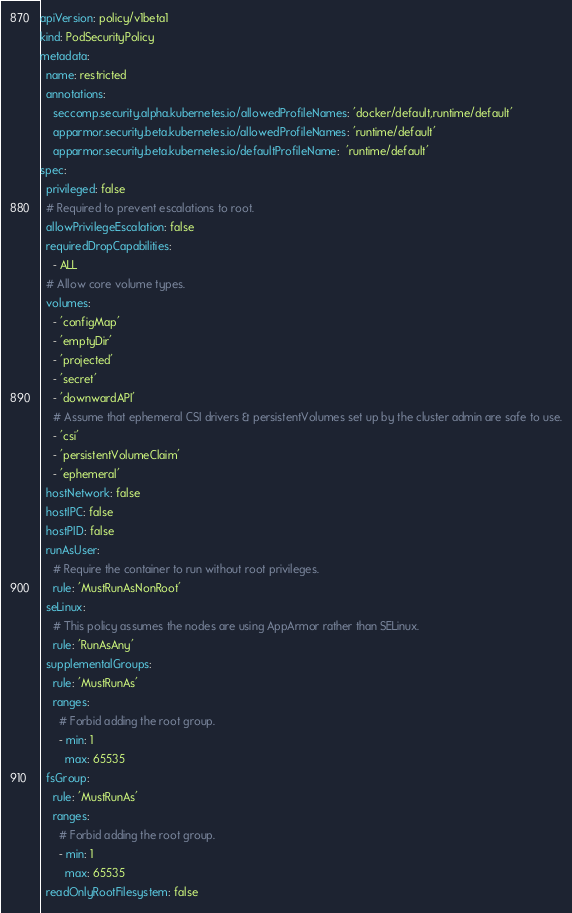Convert code to text. <code><loc_0><loc_0><loc_500><loc_500><_YAML_>apiVersion: policy/v1beta1
kind: PodSecurityPolicy
metadata:
  name: restricted
  annotations:
    seccomp.security.alpha.kubernetes.io/allowedProfileNames: 'docker/default,runtime/default'
    apparmor.security.beta.kubernetes.io/allowedProfileNames: 'runtime/default'
    apparmor.security.beta.kubernetes.io/defaultProfileName:  'runtime/default'
spec:
  privileged: false
  # Required to prevent escalations to root.
  allowPrivilegeEscalation: false
  requiredDropCapabilities:
    - ALL
  # Allow core volume types.
  volumes:
    - 'configMap'
    - 'emptyDir'
    - 'projected'
    - 'secret'
    - 'downwardAPI'
    # Assume that ephemeral CSI drivers & persistentVolumes set up by the cluster admin are safe to use.
    - 'csi'
    - 'persistentVolumeClaim'
    - 'ephemeral'
  hostNetwork: false
  hostIPC: false
  hostPID: false
  runAsUser:
    # Require the container to run without root privileges.
    rule: 'MustRunAsNonRoot'
  seLinux:
    # This policy assumes the nodes are using AppArmor rather than SELinux.
    rule: 'RunAsAny'
  supplementalGroups:
    rule: 'MustRunAs'
    ranges:
      # Forbid adding the root group.
      - min: 1
        max: 65535
  fsGroup:
    rule: 'MustRunAs'
    ranges:
      # Forbid adding the root group.
      - min: 1
        max: 65535
  readOnlyRootFilesystem: false
</code> 